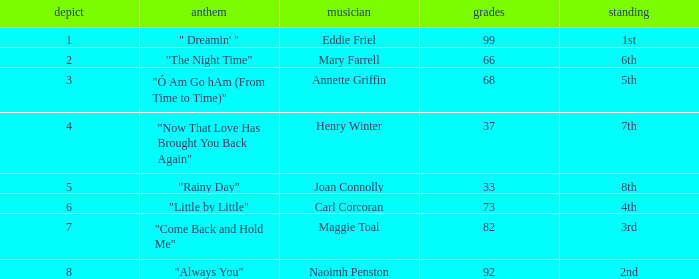Which tune has over 66 points, a tie exceeding 3, and holds the 3rd position in ranking? "Come Back and Hold Me". 